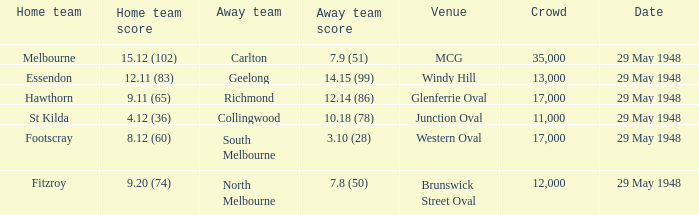In the match where footscray was the home team, how much did they score? 8.12 (60). 